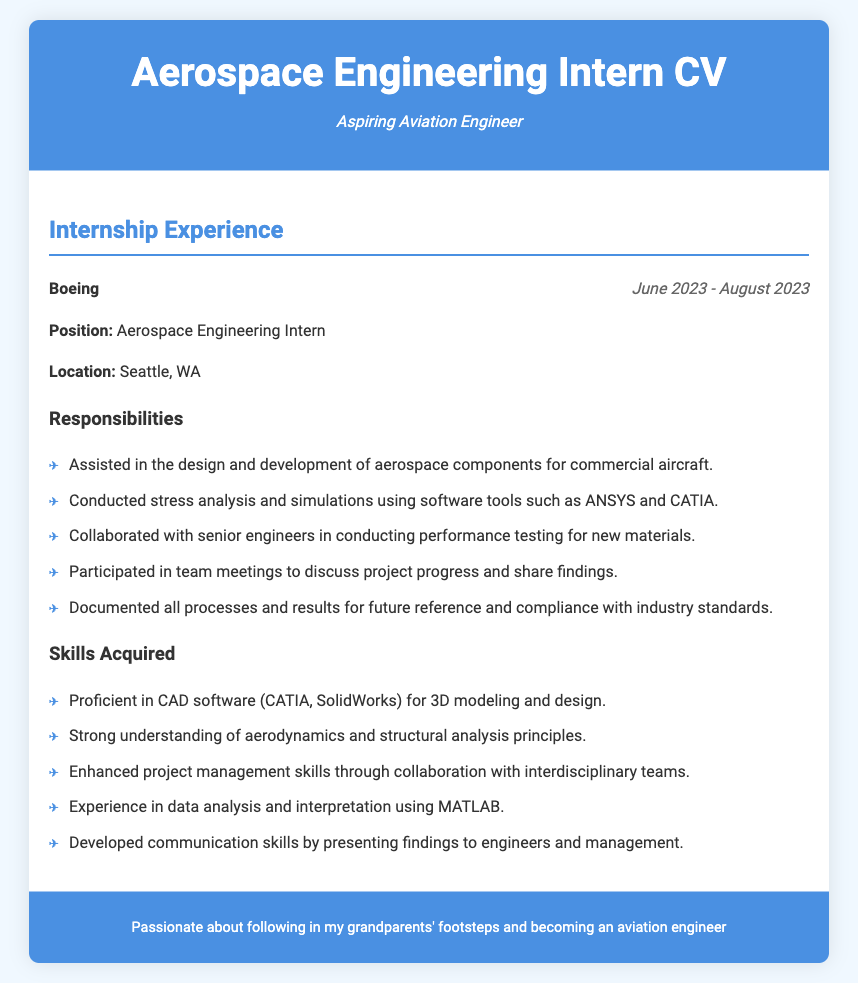What company did the internship take place at? The company's name is mentioned at the beginning of the internship experience section.
Answer: Boeing What was the position held during the internship? The position is clearly listed under the internship details.
Answer: Aerospace Engineering Intern In which city was the internship located? The location is stated in the internship information section.
Answer: Seattle, WA What were the start and end dates of the internship? The duration of the internship is provided in the experience header.
Answer: June 2023 - August 2023 Which software tools were used for stress analysis? The tools are specifically listed in the responsibilities section of the document.
Answer: ANSYS and CATIA What type of analysis was focused on during the internship? The specific type of analysis is mentioned in the responsibilities detail.
Answer: Stress analysis How many skills were acquired during the internship? The number of skills listed under skills acquired is counted.
Answer: Five What kind of skills were enhanced through collaboration? This is mentioned among the skills acquired in the document.
Answer: Project management skills Which engineering principles were reinforced during the internship? The principles are directly listed in the skills acquired section.
Answer: Aerodynamics and structural analysis principles 